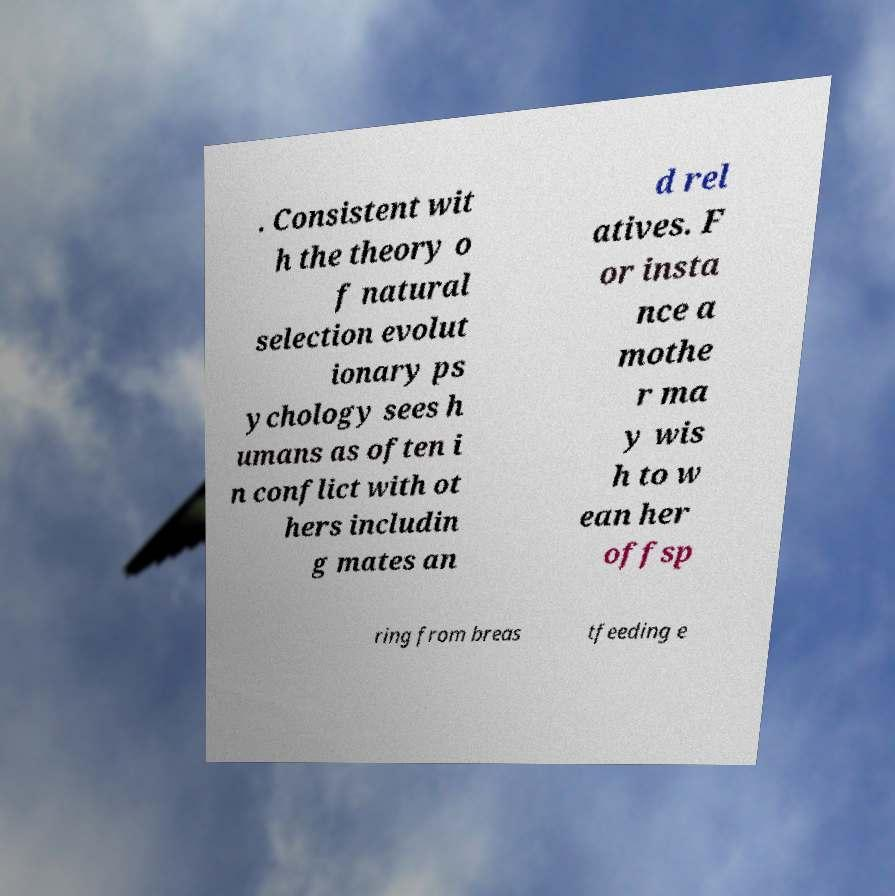Could you assist in decoding the text presented in this image and type it out clearly? . Consistent wit h the theory o f natural selection evolut ionary ps ychology sees h umans as often i n conflict with ot hers includin g mates an d rel atives. F or insta nce a mothe r ma y wis h to w ean her offsp ring from breas tfeeding e 